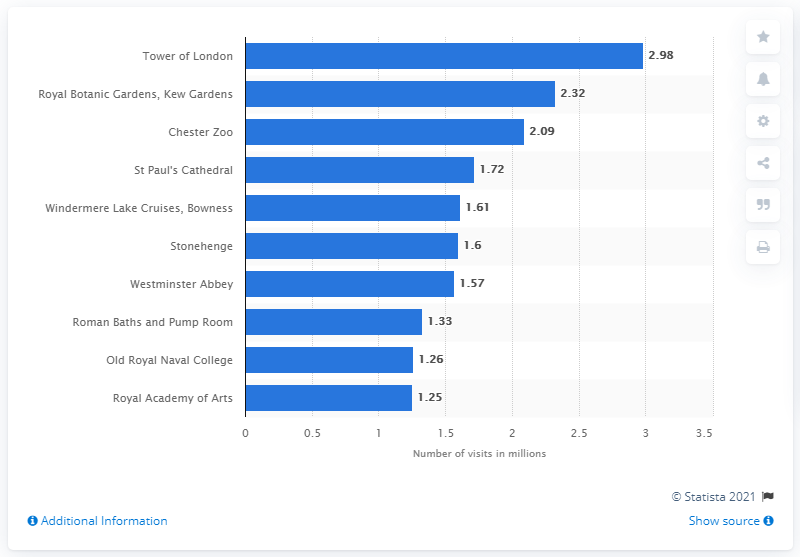List a handful of essential elements in this visual. In 2019, the Tower of London was visited by 2.98 million people. 